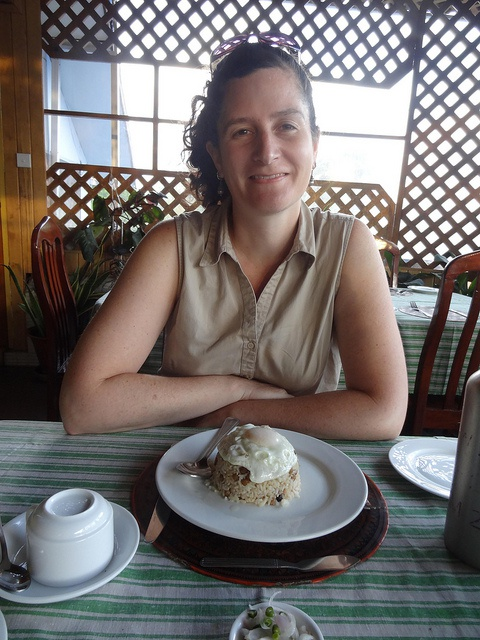Describe the objects in this image and their specific colors. I can see people in black, gray, maroon, and darkgray tones, dining table in black, gray, and teal tones, chair in black, gray, maroon, and lightgray tones, cup in black, lightblue, darkgray, gray, and lightgray tones, and cake in black, darkgray, gray, and lightgray tones in this image. 